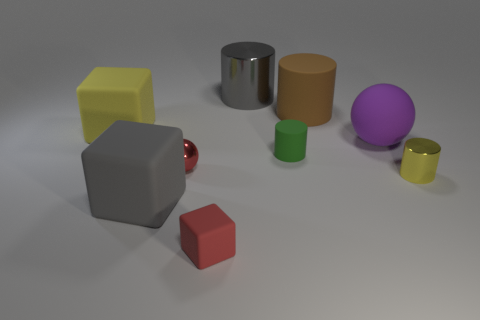Subtract 1 cylinders. How many cylinders are left? 3 Subtract all balls. How many objects are left? 7 Add 3 gray metallic cylinders. How many gray metallic cylinders exist? 4 Subtract 1 red blocks. How many objects are left? 8 Subtract all tiny red things. Subtract all tiny yellow cylinders. How many objects are left? 6 Add 6 green matte cylinders. How many green matte cylinders are left? 7 